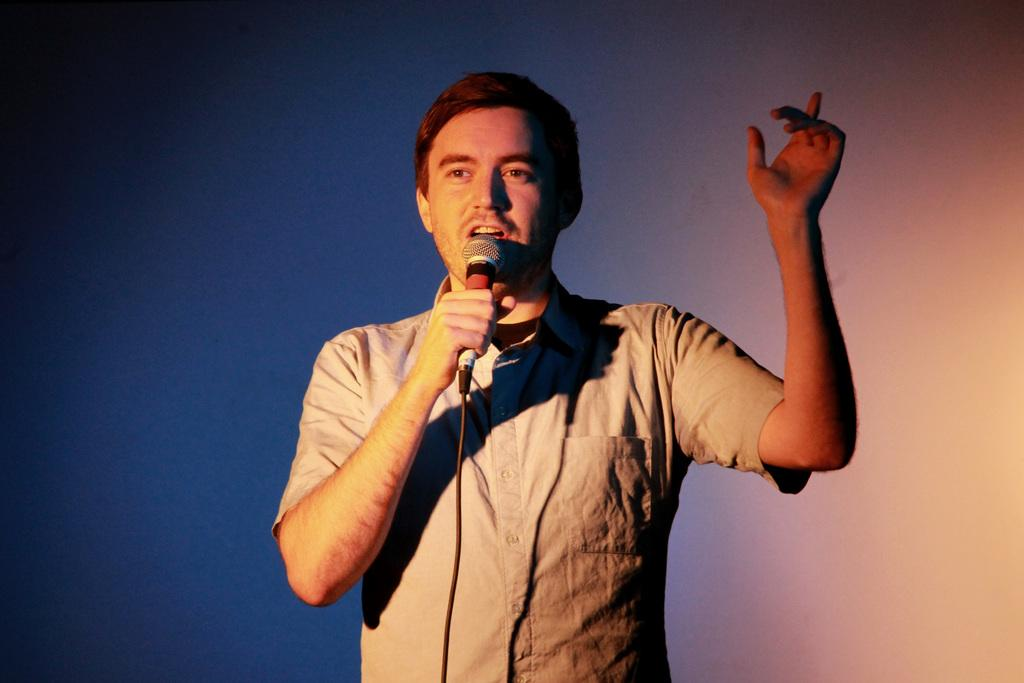Who is the main subject in the image? There is a man in the image. What is the man doing in the image? The man is speaking in the image. How is the man amplifying his voice in the image? The man is using a microphone to speak in the image. What type of wool is being spun by the man in the image? There is no wool or spinning activity present in the image; the man is speaking using a microphone. 